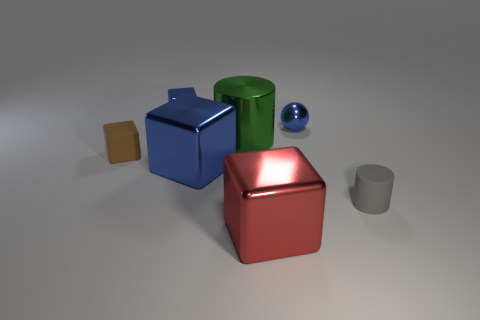What number of other objects are the same color as the matte cylinder?
Make the answer very short. 0. Do the shiny sphere and the large metal block on the left side of the green metal cylinder have the same color?
Keep it short and to the point. Yes. There is a shiny object on the right side of the big metal thing that is in front of the tiny cylinder; what size is it?
Ensure brevity in your answer.  Small. How many objects are large purple metal things or small metallic things to the left of the big green shiny object?
Your answer should be compact. 1. There is a small metallic thing that is to the right of the red metallic thing; is it the same shape as the red metallic object?
Make the answer very short. No. There is a blue metallic block in front of the metal object that is on the right side of the big red object; how many shiny things are in front of it?
Provide a short and direct response. 1. Is there anything else that has the same shape as the brown object?
Your answer should be compact. Yes. What number of things are either large cyan shiny blocks or big metal blocks?
Make the answer very short. 2. There is a red object; is its shape the same as the small blue object that is left of the metallic ball?
Offer a very short reply. Yes. What shape is the matte object to the left of the green metal object?
Your response must be concise. Cube. 